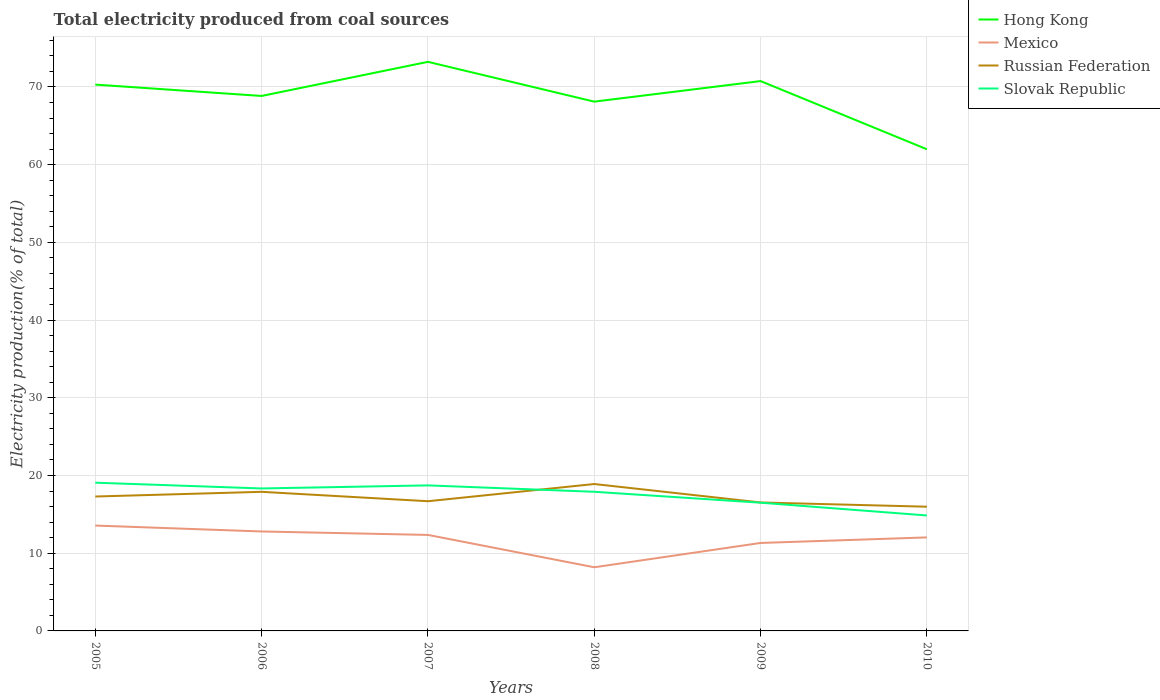Across all years, what is the maximum total electricity produced in Mexico?
Provide a short and direct response. 8.19. What is the total total electricity produced in Mexico in the graph?
Offer a terse response. 0.32. What is the difference between the highest and the second highest total electricity produced in Russian Federation?
Provide a short and direct response. 2.92. What is the difference between the highest and the lowest total electricity produced in Mexico?
Offer a very short reply. 4. How many lines are there?
Your answer should be compact. 4. What is the title of the graph?
Your answer should be very brief. Total electricity produced from coal sources. What is the label or title of the X-axis?
Provide a short and direct response. Years. What is the label or title of the Y-axis?
Your answer should be compact. Electricity production(% of total). What is the Electricity production(% of total) of Hong Kong in 2005?
Offer a terse response. 70.3. What is the Electricity production(% of total) in Mexico in 2005?
Give a very brief answer. 13.56. What is the Electricity production(% of total) of Russian Federation in 2005?
Make the answer very short. 17.3. What is the Electricity production(% of total) of Slovak Republic in 2005?
Keep it short and to the point. 19.07. What is the Electricity production(% of total) of Hong Kong in 2006?
Make the answer very short. 68.84. What is the Electricity production(% of total) of Mexico in 2006?
Give a very brief answer. 12.8. What is the Electricity production(% of total) of Russian Federation in 2006?
Keep it short and to the point. 17.9. What is the Electricity production(% of total) of Slovak Republic in 2006?
Provide a short and direct response. 18.33. What is the Electricity production(% of total) in Hong Kong in 2007?
Your answer should be compact. 73.23. What is the Electricity production(% of total) in Mexico in 2007?
Provide a short and direct response. 12.35. What is the Electricity production(% of total) of Russian Federation in 2007?
Ensure brevity in your answer.  16.69. What is the Electricity production(% of total) in Slovak Republic in 2007?
Make the answer very short. 18.73. What is the Electricity production(% of total) of Hong Kong in 2008?
Keep it short and to the point. 68.11. What is the Electricity production(% of total) of Mexico in 2008?
Ensure brevity in your answer.  8.19. What is the Electricity production(% of total) in Russian Federation in 2008?
Provide a short and direct response. 18.9. What is the Electricity production(% of total) in Slovak Republic in 2008?
Provide a short and direct response. 17.9. What is the Electricity production(% of total) in Hong Kong in 2009?
Your answer should be compact. 70.75. What is the Electricity production(% of total) of Mexico in 2009?
Provide a short and direct response. 11.32. What is the Electricity production(% of total) of Russian Federation in 2009?
Your answer should be compact. 16.53. What is the Electricity production(% of total) of Slovak Republic in 2009?
Make the answer very short. 16.5. What is the Electricity production(% of total) in Hong Kong in 2010?
Your answer should be compact. 61.98. What is the Electricity production(% of total) of Mexico in 2010?
Offer a terse response. 12.03. What is the Electricity production(% of total) of Russian Federation in 2010?
Provide a short and direct response. 15.98. What is the Electricity production(% of total) of Slovak Republic in 2010?
Keep it short and to the point. 14.86. Across all years, what is the maximum Electricity production(% of total) of Hong Kong?
Offer a terse response. 73.23. Across all years, what is the maximum Electricity production(% of total) of Mexico?
Make the answer very short. 13.56. Across all years, what is the maximum Electricity production(% of total) of Russian Federation?
Offer a terse response. 18.9. Across all years, what is the maximum Electricity production(% of total) in Slovak Republic?
Your answer should be compact. 19.07. Across all years, what is the minimum Electricity production(% of total) of Hong Kong?
Give a very brief answer. 61.98. Across all years, what is the minimum Electricity production(% of total) of Mexico?
Your answer should be very brief. 8.19. Across all years, what is the minimum Electricity production(% of total) in Russian Federation?
Your response must be concise. 15.98. Across all years, what is the minimum Electricity production(% of total) in Slovak Republic?
Provide a succinct answer. 14.86. What is the total Electricity production(% of total) of Hong Kong in the graph?
Keep it short and to the point. 413.19. What is the total Electricity production(% of total) of Mexico in the graph?
Ensure brevity in your answer.  70.25. What is the total Electricity production(% of total) in Russian Federation in the graph?
Provide a succinct answer. 103.3. What is the total Electricity production(% of total) of Slovak Republic in the graph?
Offer a very short reply. 105.39. What is the difference between the Electricity production(% of total) in Hong Kong in 2005 and that in 2006?
Make the answer very short. 1.46. What is the difference between the Electricity production(% of total) in Mexico in 2005 and that in 2006?
Ensure brevity in your answer.  0.76. What is the difference between the Electricity production(% of total) in Russian Federation in 2005 and that in 2006?
Provide a succinct answer. -0.6. What is the difference between the Electricity production(% of total) in Slovak Republic in 2005 and that in 2006?
Keep it short and to the point. 0.74. What is the difference between the Electricity production(% of total) in Hong Kong in 2005 and that in 2007?
Offer a very short reply. -2.93. What is the difference between the Electricity production(% of total) in Mexico in 2005 and that in 2007?
Ensure brevity in your answer.  1.2. What is the difference between the Electricity production(% of total) of Russian Federation in 2005 and that in 2007?
Make the answer very short. 0.61. What is the difference between the Electricity production(% of total) in Slovak Republic in 2005 and that in 2007?
Make the answer very short. 0.35. What is the difference between the Electricity production(% of total) in Hong Kong in 2005 and that in 2008?
Make the answer very short. 2.19. What is the difference between the Electricity production(% of total) in Mexico in 2005 and that in 2008?
Give a very brief answer. 5.37. What is the difference between the Electricity production(% of total) of Russian Federation in 2005 and that in 2008?
Provide a short and direct response. -1.61. What is the difference between the Electricity production(% of total) of Slovak Republic in 2005 and that in 2008?
Your response must be concise. 1.17. What is the difference between the Electricity production(% of total) in Hong Kong in 2005 and that in 2009?
Provide a short and direct response. -0.45. What is the difference between the Electricity production(% of total) in Mexico in 2005 and that in 2009?
Keep it short and to the point. 2.24. What is the difference between the Electricity production(% of total) of Russian Federation in 2005 and that in 2009?
Your answer should be very brief. 0.77. What is the difference between the Electricity production(% of total) in Slovak Republic in 2005 and that in 2009?
Your answer should be very brief. 2.58. What is the difference between the Electricity production(% of total) in Hong Kong in 2005 and that in 2010?
Keep it short and to the point. 8.32. What is the difference between the Electricity production(% of total) of Mexico in 2005 and that in 2010?
Offer a terse response. 1.52. What is the difference between the Electricity production(% of total) of Russian Federation in 2005 and that in 2010?
Offer a terse response. 1.31. What is the difference between the Electricity production(% of total) of Slovak Republic in 2005 and that in 2010?
Offer a terse response. 4.22. What is the difference between the Electricity production(% of total) in Hong Kong in 2006 and that in 2007?
Give a very brief answer. -4.39. What is the difference between the Electricity production(% of total) of Mexico in 2006 and that in 2007?
Offer a very short reply. 0.44. What is the difference between the Electricity production(% of total) of Russian Federation in 2006 and that in 2007?
Provide a succinct answer. 1.21. What is the difference between the Electricity production(% of total) of Slovak Republic in 2006 and that in 2007?
Your response must be concise. -0.39. What is the difference between the Electricity production(% of total) of Hong Kong in 2006 and that in 2008?
Your answer should be compact. 0.73. What is the difference between the Electricity production(% of total) of Mexico in 2006 and that in 2008?
Your response must be concise. 4.61. What is the difference between the Electricity production(% of total) in Russian Federation in 2006 and that in 2008?
Offer a terse response. -1. What is the difference between the Electricity production(% of total) of Slovak Republic in 2006 and that in 2008?
Provide a short and direct response. 0.43. What is the difference between the Electricity production(% of total) in Hong Kong in 2006 and that in 2009?
Your response must be concise. -1.91. What is the difference between the Electricity production(% of total) in Mexico in 2006 and that in 2009?
Offer a terse response. 1.48. What is the difference between the Electricity production(% of total) of Russian Federation in 2006 and that in 2009?
Your response must be concise. 1.37. What is the difference between the Electricity production(% of total) of Slovak Republic in 2006 and that in 2009?
Keep it short and to the point. 1.83. What is the difference between the Electricity production(% of total) in Hong Kong in 2006 and that in 2010?
Make the answer very short. 6.86. What is the difference between the Electricity production(% of total) in Mexico in 2006 and that in 2010?
Provide a succinct answer. 0.76. What is the difference between the Electricity production(% of total) in Russian Federation in 2006 and that in 2010?
Give a very brief answer. 1.91. What is the difference between the Electricity production(% of total) of Slovak Republic in 2006 and that in 2010?
Offer a very short reply. 3.48. What is the difference between the Electricity production(% of total) in Hong Kong in 2007 and that in 2008?
Your response must be concise. 5.12. What is the difference between the Electricity production(% of total) in Mexico in 2007 and that in 2008?
Offer a terse response. 4.16. What is the difference between the Electricity production(% of total) of Russian Federation in 2007 and that in 2008?
Your answer should be very brief. -2.21. What is the difference between the Electricity production(% of total) in Slovak Republic in 2007 and that in 2008?
Provide a short and direct response. 0.82. What is the difference between the Electricity production(% of total) in Hong Kong in 2007 and that in 2009?
Provide a short and direct response. 2.48. What is the difference between the Electricity production(% of total) in Mexico in 2007 and that in 2009?
Your answer should be very brief. 1.03. What is the difference between the Electricity production(% of total) of Russian Federation in 2007 and that in 2009?
Your response must be concise. 0.16. What is the difference between the Electricity production(% of total) of Slovak Republic in 2007 and that in 2009?
Offer a terse response. 2.23. What is the difference between the Electricity production(% of total) in Hong Kong in 2007 and that in 2010?
Ensure brevity in your answer.  11.25. What is the difference between the Electricity production(% of total) of Mexico in 2007 and that in 2010?
Keep it short and to the point. 0.32. What is the difference between the Electricity production(% of total) in Russian Federation in 2007 and that in 2010?
Give a very brief answer. 0.71. What is the difference between the Electricity production(% of total) in Slovak Republic in 2007 and that in 2010?
Offer a terse response. 3.87. What is the difference between the Electricity production(% of total) in Hong Kong in 2008 and that in 2009?
Give a very brief answer. -2.64. What is the difference between the Electricity production(% of total) of Mexico in 2008 and that in 2009?
Give a very brief answer. -3.13. What is the difference between the Electricity production(% of total) of Russian Federation in 2008 and that in 2009?
Make the answer very short. 2.37. What is the difference between the Electricity production(% of total) in Slovak Republic in 2008 and that in 2009?
Ensure brevity in your answer.  1.41. What is the difference between the Electricity production(% of total) in Hong Kong in 2008 and that in 2010?
Your response must be concise. 6.13. What is the difference between the Electricity production(% of total) in Mexico in 2008 and that in 2010?
Your answer should be compact. -3.84. What is the difference between the Electricity production(% of total) in Russian Federation in 2008 and that in 2010?
Make the answer very short. 2.92. What is the difference between the Electricity production(% of total) in Slovak Republic in 2008 and that in 2010?
Offer a terse response. 3.05. What is the difference between the Electricity production(% of total) of Hong Kong in 2009 and that in 2010?
Your answer should be compact. 8.78. What is the difference between the Electricity production(% of total) of Mexico in 2009 and that in 2010?
Offer a very short reply. -0.71. What is the difference between the Electricity production(% of total) of Russian Federation in 2009 and that in 2010?
Keep it short and to the point. 0.55. What is the difference between the Electricity production(% of total) in Slovak Republic in 2009 and that in 2010?
Your answer should be compact. 1.64. What is the difference between the Electricity production(% of total) of Hong Kong in 2005 and the Electricity production(% of total) of Mexico in 2006?
Provide a succinct answer. 57.5. What is the difference between the Electricity production(% of total) of Hong Kong in 2005 and the Electricity production(% of total) of Russian Federation in 2006?
Provide a short and direct response. 52.4. What is the difference between the Electricity production(% of total) in Hong Kong in 2005 and the Electricity production(% of total) in Slovak Republic in 2006?
Your response must be concise. 51.97. What is the difference between the Electricity production(% of total) of Mexico in 2005 and the Electricity production(% of total) of Russian Federation in 2006?
Your response must be concise. -4.34. What is the difference between the Electricity production(% of total) of Mexico in 2005 and the Electricity production(% of total) of Slovak Republic in 2006?
Make the answer very short. -4.78. What is the difference between the Electricity production(% of total) of Russian Federation in 2005 and the Electricity production(% of total) of Slovak Republic in 2006?
Offer a terse response. -1.04. What is the difference between the Electricity production(% of total) of Hong Kong in 2005 and the Electricity production(% of total) of Mexico in 2007?
Provide a short and direct response. 57.94. What is the difference between the Electricity production(% of total) of Hong Kong in 2005 and the Electricity production(% of total) of Russian Federation in 2007?
Your response must be concise. 53.61. What is the difference between the Electricity production(% of total) of Hong Kong in 2005 and the Electricity production(% of total) of Slovak Republic in 2007?
Your response must be concise. 51.57. What is the difference between the Electricity production(% of total) in Mexico in 2005 and the Electricity production(% of total) in Russian Federation in 2007?
Give a very brief answer. -3.13. What is the difference between the Electricity production(% of total) of Mexico in 2005 and the Electricity production(% of total) of Slovak Republic in 2007?
Provide a succinct answer. -5.17. What is the difference between the Electricity production(% of total) in Russian Federation in 2005 and the Electricity production(% of total) in Slovak Republic in 2007?
Give a very brief answer. -1.43. What is the difference between the Electricity production(% of total) of Hong Kong in 2005 and the Electricity production(% of total) of Mexico in 2008?
Offer a very short reply. 62.11. What is the difference between the Electricity production(% of total) in Hong Kong in 2005 and the Electricity production(% of total) in Russian Federation in 2008?
Keep it short and to the point. 51.4. What is the difference between the Electricity production(% of total) in Hong Kong in 2005 and the Electricity production(% of total) in Slovak Republic in 2008?
Provide a short and direct response. 52.39. What is the difference between the Electricity production(% of total) of Mexico in 2005 and the Electricity production(% of total) of Russian Federation in 2008?
Give a very brief answer. -5.35. What is the difference between the Electricity production(% of total) of Mexico in 2005 and the Electricity production(% of total) of Slovak Republic in 2008?
Provide a succinct answer. -4.35. What is the difference between the Electricity production(% of total) in Russian Federation in 2005 and the Electricity production(% of total) in Slovak Republic in 2008?
Offer a terse response. -0.61. What is the difference between the Electricity production(% of total) of Hong Kong in 2005 and the Electricity production(% of total) of Mexico in 2009?
Your answer should be very brief. 58.98. What is the difference between the Electricity production(% of total) in Hong Kong in 2005 and the Electricity production(% of total) in Russian Federation in 2009?
Your response must be concise. 53.77. What is the difference between the Electricity production(% of total) in Hong Kong in 2005 and the Electricity production(% of total) in Slovak Republic in 2009?
Offer a very short reply. 53.8. What is the difference between the Electricity production(% of total) of Mexico in 2005 and the Electricity production(% of total) of Russian Federation in 2009?
Provide a short and direct response. -2.97. What is the difference between the Electricity production(% of total) in Mexico in 2005 and the Electricity production(% of total) in Slovak Republic in 2009?
Your response must be concise. -2.94. What is the difference between the Electricity production(% of total) in Russian Federation in 2005 and the Electricity production(% of total) in Slovak Republic in 2009?
Provide a short and direct response. 0.8. What is the difference between the Electricity production(% of total) of Hong Kong in 2005 and the Electricity production(% of total) of Mexico in 2010?
Make the answer very short. 58.26. What is the difference between the Electricity production(% of total) of Hong Kong in 2005 and the Electricity production(% of total) of Russian Federation in 2010?
Make the answer very short. 54.31. What is the difference between the Electricity production(% of total) of Hong Kong in 2005 and the Electricity production(% of total) of Slovak Republic in 2010?
Your answer should be compact. 55.44. What is the difference between the Electricity production(% of total) in Mexico in 2005 and the Electricity production(% of total) in Russian Federation in 2010?
Keep it short and to the point. -2.43. What is the difference between the Electricity production(% of total) in Mexico in 2005 and the Electricity production(% of total) in Slovak Republic in 2010?
Provide a succinct answer. -1.3. What is the difference between the Electricity production(% of total) in Russian Federation in 2005 and the Electricity production(% of total) in Slovak Republic in 2010?
Your response must be concise. 2.44. What is the difference between the Electricity production(% of total) in Hong Kong in 2006 and the Electricity production(% of total) in Mexico in 2007?
Keep it short and to the point. 56.48. What is the difference between the Electricity production(% of total) in Hong Kong in 2006 and the Electricity production(% of total) in Russian Federation in 2007?
Your response must be concise. 52.15. What is the difference between the Electricity production(% of total) in Hong Kong in 2006 and the Electricity production(% of total) in Slovak Republic in 2007?
Your response must be concise. 50.11. What is the difference between the Electricity production(% of total) in Mexico in 2006 and the Electricity production(% of total) in Russian Federation in 2007?
Ensure brevity in your answer.  -3.89. What is the difference between the Electricity production(% of total) of Mexico in 2006 and the Electricity production(% of total) of Slovak Republic in 2007?
Give a very brief answer. -5.93. What is the difference between the Electricity production(% of total) in Russian Federation in 2006 and the Electricity production(% of total) in Slovak Republic in 2007?
Offer a very short reply. -0.83. What is the difference between the Electricity production(% of total) of Hong Kong in 2006 and the Electricity production(% of total) of Mexico in 2008?
Your response must be concise. 60.65. What is the difference between the Electricity production(% of total) of Hong Kong in 2006 and the Electricity production(% of total) of Russian Federation in 2008?
Provide a succinct answer. 49.94. What is the difference between the Electricity production(% of total) of Hong Kong in 2006 and the Electricity production(% of total) of Slovak Republic in 2008?
Provide a short and direct response. 50.93. What is the difference between the Electricity production(% of total) of Mexico in 2006 and the Electricity production(% of total) of Russian Federation in 2008?
Keep it short and to the point. -6.1. What is the difference between the Electricity production(% of total) in Mexico in 2006 and the Electricity production(% of total) in Slovak Republic in 2008?
Your answer should be compact. -5.11. What is the difference between the Electricity production(% of total) in Russian Federation in 2006 and the Electricity production(% of total) in Slovak Republic in 2008?
Offer a very short reply. -0.01. What is the difference between the Electricity production(% of total) in Hong Kong in 2006 and the Electricity production(% of total) in Mexico in 2009?
Give a very brief answer. 57.52. What is the difference between the Electricity production(% of total) of Hong Kong in 2006 and the Electricity production(% of total) of Russian Federation in 2009?
Provide a succinct answer. 52.31. What is the difference between the Electricity production(% of total) of Hong Kong in 2006 and the Electricity production(% of total) of Slovak Republic in 2009?
Your answer should be compact. 52.34. What is the difference between the Electricity production(% of total) of Mexico in 2006 and the Electricity production(% of total) of Russian Federation in 2009?
Give a very brief answer. -3.73. What is the difference between the Electricity production(% of total) of Mexico in 2006 and the Electricity production(% of total) of Slovak Republic in 2009?
Offer a very short reply. -3.7. What is the difference between the Electricity production(% of total) of Russian Federation in 2006 and the Electricity production(% of total) of Slovak Republic in 2009?
Give a very brief answer. 1.4. What is the difference between the Electricity production(% of total) of Hong Kong in 2006 and the Electricity production(% of total) of Mexico in 2010?
Offer a very short reply. 56.8. What is the difference between the Electricity production(% of total) of Hong Kong in 2006 and the Electricity production(% of total) of Russian Federation in 2010?
Give a very brief answer. 52.85. What is the difference between the Electricity production(% of total) in Hong Kong in 2006 and the Electricity production(% of total) in Slovak Republic in 2010?
Keep it short and to the point. 53.98. What is the difference between the Electricity production(% of total) of Mexico in 2006 and the Electricity production(% of total) of Russian Federation in 2010?
Offer a very short reply. -3.19. What is the difference between the Electricity production(% of total) in Mexico in 2006 and the Electricity production(% of total) in Slovak Republic in 2010?
Give a very brief answer. -2.06. What is the difference between the Electricity production(% of total) of Russian Federation in 2006 and the Electricity production(% of total) of Slovak Republic in 2010?
Your answer should be compact. 3.04. What is the difference between the Electricity production(% of total) of Hong Kong in 2007 and the Electricity production(% of total) of Mexico in 2008?
Give a very brief answer. 65.04. What is the difference between the Electricity production(% of total) in Hong Kong in 2007 and the Electricity production(% of total) in Russian Federation in 2008?
Ensure brevity in your answer.  54.32. What is the difference between the Electricity production(% of total) of Hong Kong in 2007 and the Electricity production(% of total) of Slovak Republic in 2008?
Your answer should be very brief. 55.32. What is the difference between the Electricity production(% of total) in Mexico in 2007 and the Electricity production(% of total) in Russian Federation in 2008?
Provide a short and direct response. -6.55. What is the difference between the Electricity production(% of total) of Mexico in 2007 and the Electricity production(% of total) of Slovak Republic in 2008?
Offer a terse response. -5.55. What is the difference between the Electricity production(% of total) of Russian Federation in 2007 and the Electricity production(% of total) of Slovak Republic in 2008?
Ensure brevity in your answer.  -1.21. What is the difference between the Electricity production(% of total) of Hong Kong in 2007 and the Electricity production(% of total) of Mexico in 2009?
Provide a short and direct response. 61.91. What is the difference between the Electricity production(% of total) in Hong Kong in 2007 and the Electricity production(% of total) in Russian Federation in 2009?
Offer a very short reply. 56.7. What is the difference between the Electricity production(% of total) of Hong Kong in 2007 and the Electricity production(% of total) of Slovak Republic in 2009?
Provide a short and direct response. 56.73. What is the difference between the Electricity production(% of total) of Mexico in 2007 and the Electricity production(% of total) of Russian Federation in 2009?
Provide a short and direct response. -4.18. What is the difference between the Electricity production(% of total) of Mexico in 2007 and the Electricity production(% of total) of Slovak Republic in 2009?
Provide a short and direct response. -4.14. What is the difference between the Electricity production(% of total) in Russian Federation in 2007 and the Electricity production(% of total) in Slovak Republic in 2009?
Your answer should be compact. 0.19. What is the difference between the Electricity production(% of total) in Hong Kong in 2007 and the Electricity production(% of total) in Mexico in 2010?
Your answer should be very brief. 61.19. What is the difference between the Electricity production(% of total) of Hong Kong in 2007 and the Electricity production(% of total) of Russian Federation in 2010?
Provide a succinct answer. 57.24. What is the difference between the Electricity production(% of total) in Hong Kong in 2007 and the Electricity production(% of total) in Slovak Republic in 2010?
Ensure brevity in your answer.  58.37. What is the difference between the Electricity production(% of total) of Mexico in 2007 and the Electricity production(% of total) of Russian Federation in 2010?
Keep it short and to the point. -3.63. What is the difference between the Electricity production(% of total) in Mexico in 2007 and the Electricity production(% of total) in Slovak Republic in 2010?
Your response must be concise. -2.5. What is the difference between the Electricity production(% of total) of Russian Federation in 2007 and the Electricity production(% of total) of Slovak Republic in 2010?
Provide a short and direct response. 1.83. What is the difference between the Electricity production(% of total) in Hong Kong in 2008 and the Electricity production(% of total) in Mexico in 2009?
Offer a terse response. 56.79. What is the difference between the Electricity production(% of total) of Hong Kong in 2008 and the Electricity production(% of total) of Russian Federation in 2009?
Provide a succinct answer. 51.58. What is the difference between the Electricity production(% of total) of Hong Kong in 2008 and the Electricity production(% of total) of Slovak Republic in 2009?
Your response must be concise. 51.61. What is the difference between the Electricity production(% of total) in Mexico in 2008 and the Electricity production(% of total) in Russian Federation in 2009?
Offer a very short reply. -8.34. What is the difference between the Electricity production(% of total) in Mexico in 2008 and the Electricity production(% of total) in Slovak Republic in 2009?
Make the answer very short. -8.31. What is the difference between the Electricity production(% of total) in Russian Federation in 2008 and the Electricity production(% of total) in Slovak Republic in 2009?
Offer a very short reply. 2.4. What is the difference between the Electricity production(% of total) of Hong Kong in 2008 and the Electricity production(% of total) of Mexico in 2010?
Your answer should be compact. 56.07. What is the difference between the Electricity production(% of total) of Hong Kong in 2008 and the Electricity production(% of total) of Russian Federation in 2010?
Your response must be concise. 52.12. What is the difference between the Electricity production(% of total) in Hong Kong in 2008 and the Electricity production(% of total) in Slovak Republic in 2010?
Keep it short and to the point. 53.25. What is the difference between the Electricity production(% of total) in Mexico in 2008 and the Electricity production(% of total) in Russian Federation in 2010?
Offer a terse response. -7.79. What is the difference between the Electricity production(% of total) of Mexico in 2008 and the Electricity production(% of total) of Slovak Republic in 2010?
Make the answer very short. -6.67. What is the difference between the Electricity production(% of total) in Russian Federation in 2008 and the Electricity production(% of total) in Slovak Republic in 2010?
Your answer should be compact. 4.05. What is the difference between the Electricity production(% of total) in Hong Kong in 2009 and the Electricity production(% of total) in Mexico in 2010?
Offer a very short reply. 58.72. What is the difference between the Electricity production(% of total) of Hong Kong in 2009 and the Electricity production(% of total) of Russian Federation in 2010?
Your answer should be compact. 54.77. What is the difference between the Electricity production(% of total) of Hong Kong in 2009 and the Electricity production(% of total) of Slovak Republic in 2010?
Your answer should be compact. 55.89. What is the difference between the Electricity production(% of total) in Mexico in 2009 and the Electricity production(% of total) in Russian Federation in 2010?
Ensure brevity in your answer.  -4.66. What is the difference between the Electricity production(% of total) in Mexico in 2009 and the Electricity production(% of total) in Slovak Republic in 2010?
Offer a very short reply. -3.54. What is the difference between the Electricity production(% of total) in Russian Federation in 2009 and the Electricity production(% of total) in Slovak Republic in 2010?
Offer a terse response. 1.67. What is the average Electricity production(% of total) of Hong Kong per year?
Provide a succinct answer. 68.87. What is the average Electricity production(% of total) in Mexico per year?
Your response must be concise. 11.71. What is the average Electricity production(% of total) in Russian Federation per year?
Make the answer very short. 17.22. What is the average Electricity production(% of total) in Slovak Republic per year?
Your answer should be compact. 17.56. In the year 2005, what is the difference between the Electricity production(% of total) of Hong Kong and Electricity production(% of total) of Mexico?
Your answer should be very brief. 56.74. In the year 2005, what is the difference between the Electricity production(% of total) of Hong Kong and Electricity production(% of total) of Russian Federation?
Give a very brief answer. 53. In the year 2005, what is the difference between the Electricity production(% of total) in Hong Kong and Electricity production(% of total) in Slovak Republic?
Make the answer very short. 51.22. In the year 2005, what is the difference between the Electricity production(% of total) in Mexico and Electricity production(% of total) in Russian Federation?
Your answer should be compact. -3.74. In the year 2005, what is the difference between the Electricity production(% of total) of Mexico and Electricity production(% of total) of Slovak Republic?
Ensure brevity in your answer.  -5.52. In the year 2005, what is the difference between the Electricity production(% of total) of Russian Federation and Electricity production(% of total) of Slovak Republic?
Your answer should be compact. -1.78. In the year 2006, what is the difference between the Electricity production(% of total) in Hong Kong and Electricity production(% of total) in Mexico?
Offer a terse response. 56.04. In the year 2006, what is the difference between the Electricity production(% of total) of Hong Kong and Electricity production(% of total) of Russian Federation?
Offer a terse response. 50.94. In the year 2006, what is the difference between the Electricity production(% of total) in Hong Kong and Electricity production(% of total) in Slovak Republic?
Your answer should be very brief. 50.51. In the year 2006, what is the difference between the Electricity production(% of total) of Mexico and Electricity production(% of total) of Russian Federation?
Provide a short and direct response. -5.1. In the year 2006, what is the difference between the Electricity production(% of total) in Mexico and Electricity production(% of total) in Slovak Republic?
Your answer should be compact. -5.53. In the year 2006, what is the difference between the Electricity production(% of total) of Russian Federation and Electricity production(% of total) of Slovak Republic?
Provide a succinct answer. -0.43. In the year 2007, what is the difference between the Electricity production(% of total) of Hong Kong and Electricity production(% of total) of Mexico?
Your answer should be compact. 60.87. In the year 2007, what is the difference between the Electricity production(% of total) in Hong Kong and Electricity production(% of total) in Russian Federation?
Ensure brevity in your answer.  56.54. In the year 2007, what is the difference between the Electricity production(% of total) in Hong Kong and Electricity production(% of total) in Slovak Republic?
Your answer should be very brief. 54.5. In the year 2007, what is the difference between the Electricity production(% of total) in Mexico and Electricity production(% of total) in Russian Federation?
Ensure brevity in your answer.  -4.34. In the year 2007, what is the difference between the Electricity production(% of total) in Mexico and Electricity production(% of total) in Slovak Republic?
Provide a short and direct response. -6.37. In the year 2007, what is the difference between the Electricity production(% of total) of Russian Federation and Electricity production(% of total) of Slovak Republic?
Give a very brief answer. -2.04. In the year 2008, what is the difference between the Electricity production(% of total) of Hong Kong and Electricity production(% of total) of Mexico?
Provide a succinct answer. 59.91. In the year 2008, what is the difference between the Electricity production(% of total) in Hong Kong and Electricity production(% of total) in Russian Federation?
Your answer should be very brief. 49.2. In the year 2008, what is the difference between the Electricity production(% of total) of Hong Kong and Electricity production(% of total) of Slovak Republic?
Your answer should be very brief. 50.2. In the year 2008, what is the difference between the Electricity production(% of total) of Mexico and Electricity production(% of total) of Russian Federation?
Offer a terse response. -10.71. In the year 2008, what is the difference between the Electricity production(% of total) in Mexico and Electricity production(% of total) in Slovak Republic?
Provide a short and direct response. -9.71. In the year 2009, what is the difference between the Electricity production(% of total) of Hong Kong and Electricity production(% of total) of Mexico?
Your response must be concise. 59.43. In the year 2009, what is the difference between the Electricity production(% of total) of Hong Kong and Electricity production(% of total) of Russian Federation?
Give a very brief answer. 54.22. In the year 2009, what is the difference between the Electricity production(% of total) of Hong Kong and Electricity production(% of total) of Slovak Republic?
Give a very brief answer. 54.25. In the year 2009, what is the difference between the Electricity production(% of total) of Mexico and Electricity production(% of total) of Russian Federation?
Make the answer very short. -5.21. In the year 2009, what is the difference between the Electricity production(% of total) of Mexico and Electricity production(% of total) of Slovak Republic?
Ensure brevity in your answer.  -5.18. In the year 2009, what is the difference between the Electricity production(% of total) of Russian Federation and Electricity production(% of total) of Slovak Republic?
Provide a short and direct response. 0.03. In the year 2010, what is the difference between the Electricity production(% of total) in Hong Kong and Electricity production(% of total) in Mexico?
Offer a terse response. 49.94. In the year 2010, what is the difference between the Electricity production(% of total) of Hong Kong and Electricity production(% of total) of Russian Federation?
Your answer should be very brief. 45.99. In the year 2010, what is the difference between the Electricity production(% of total) in Hong Kong and Electricity production(% of total) in Slovak Republic?
Keep it short and to the point. 47.12. In the year 2010, what is the difference between the Electricity production(% of total) of Mexico and Electricity production(% of total) of Russian Federation?
Your response must be concise. -3.95. In the year 2010, what is the difference between the Electricity production(% of total) of Mexico and Electricity production(% of total) of Slovak Republic?
Provide a succinct answer. -2.82. In the year 2010, what is the difference between the Electricity production(% of total) of Russian Federation and Electricity production(% of total) of Slovak Republic?
Provide a succinct answer. 1.13. What is the ratio of the Electricity production(% of total) of Hong Kong in 2005 to that in 2006?
Offer a very short reply. 1.02. What is the ratio of the Electricity production(% of total) of Mexico in 2005 to that in 2006?
Keep it short and to the point. 1.06. What is the ratio of the Electricity production(% of total) of Russian Federation in 2005 to that in 2006?
Keep it short and to the point. 0.97. What is the ratio of the Electricity production(% of total) in Slovak Republic in 2005 to that in 2006?
Your response must be concise. 1.04. What is the ratio of the Electricity production(% of total) of Mexico in 2005 to that in 2007?
Keep it short and to the point. 1.1. What is the ratio of the Electricity production(% of total) in Russian Federation in 2005 to that in 2007?
Provide a succinct answer. 1.04. What is the ratio of the Electricity production(% of total) in Slovak Republic in 2005 to that in 2007?
Provide a short and direct response. 1.02. What is the ratio of the Electricity production(% of total) in Hong Kong in 2005 to that in 2008?
Offer a very short reply. 1.03. What is the ratio of the Electricity production(% of total) in Mexico in 2005 to that in 2008?
Offer a terse response. 1.66. What is the ratio of the Electricity production(% of total) in Russian Federation in 2005 to that in 2008?
Provide a short and direct response. 0.92. What is the ratio of the Electricity production(% of total) of Slovak Republic in 2005 to that in 2008?
Keep it short and to the point. 1.07. What is the ratio of the Electricity production(% of total) in Mexico in 2005 to that in 2009?
Make the answer very short. 1.2. What is the ratio of the Electricity production(% of total) of Russian Federation in 2005 to that in 2009?
Make the answer very short. 1.05. What is the ratio of the Electricity production(% of total) in Slovak Republic in 2005 to that in 2009?
Your answer should be compact. 1.16. What is the ratio of the Electricity production(% of total) in Hong Kong in 2005 to that in 2010?
Keep it short and to the point. 1.13. What is the ratio of the Electricity production(% of total) of Mexico in 2005 to that in 2010?
Your response must be concise. 1.13. What is the ratio of the Electricity production(% of total) in Russian Federation in 2005 to that in 2010?
Your answer should be very brief. 1.08. What is the ratio of the Electricity production(% of total) of Slovak Republic in 2005 to that in 2010?
Your answer should be compact. 1.28. What is the ratio of the Electricity production(% of total) of Hong Kong in 2006 to that in 2007?
Give a very brief answer. 0.94. What is the ratio of the Electricity production(% of total) of Mexico in 2006 to that in 2007?
Make the answer very short. 1.04. What is the ratio of the Electricity production(% of total) in Russian Federation in 2006 to that in 2007?
Give a very brief answer. 1.07. What is the ratio of the Electricity production(% of total) in Slovak Republic in 2006 to that in 2007?
Keep it short and to the point. 0.98. What is the ratio of the Electricity production(% of total) of Hong Kong in 2006 to that in 2008?
Provide a succinct answer. 1.01. What is the ratio of the Electricity production(% of total) of Mexico in 2006 to that in 2008?
Offer a very short reply. 1.56. What is the ratio of the Electricity production(% of total) in Russian Federation in 2006 to that in 2008?
Ensure brevity in your answer.  0.95. What is the ratio of the Electricity production(% of total) of Hong Kong in 2006 to that in 2009?
Provide a short and direct response. 0.97. What is the ratio of the Electricity production(% of total) in Mexico in 2006 to that in 2009?
Offer a very short reply. 1.13. What is the ratio of the Electricity production(% of total) in Russian Federation in 2006 to that in 2009?
Ensure brevity in your answer.  1.08. What is the ratio of the Electricity production(% of total) of Slovak Republic in 2006 to that in 2009?
Make the answer very short. 1.11. What is the ratio of the Electricity production(% of total) in Hong Kong in 2006 to that in 2010?
Make the answer very short. 1.11. What is the ratio of the Electricity production(% of total) of Mexico in 2006 to that in 2010?
Your answer should be very brief. 1.06. What is the ratio of the Electricity production(% of total) of Russian Federation in 2006 to that in 2010?
Offer a terse response. 1.12. What is the ratio of the Electricity production(% of total) in Slovak Republic in 2006 to that in 2010?
Provide a short and direct response. 1.23. What is the ratio of the Electricity production(% of total) in Hong Kong in 2007 to that in 2008?
Make the answer very short. 1.08. What is the ratio of the Electricity production(% of total) of Mexico in 2007 to that in 2008?
Provide a short and direct response. 1.51. What is the ratio of the Electricity production(% of total) in Russian Federation in 2007 to that in 2008?
Your answer should be very brief. 0.88. What is the ratio of the Electricity production(% of total) in Slovak Republic in 2007 to that in 2008?
Make the answer very short. 1.05. What is the ratio of the Electricity production(% of total) in Hong Kong in 2007 to that in 2009?
Provide a succinct answer. 1.03. What is the ratio of the Electricity production(% of total) in Mexico in 2007 to that in 2009?
Keep it short and to the point. 1.09. What is the ratio of the Electricity production(% of total) in Russian Federation in 2007 to that in 2009?
Make the answer very short. 1.01. What is the ratio of the Electricity production(% of total) of Slovak Republic in 2007 to that in 2009?
Provide a short and direct response. 1.14. What is the ratio of the Electricity production(% of total) in Hong Kong in 2007 to that in 2010?
Provide a short and direct response. 1.18. What is the ratio of the Electricity production(% of total) in Mexico in 2007 to that in 2010?
Ensure brevity in your answer.  1.03. What is the ratio of the Electricity production(% of total) of Russian Federation in 2007 to that in 2010?
Your response must be concise. 1.04. What is the ratio of the Electricity production(% of total) of Slovak Republic in 2007 to that in 2010?
Make the answer very short. 1.26. What is the ratio of the Electricity production(% of total) in Hong Kong in 2008 to that in 2009?
Your answer should be compact. 0.96. What is the ratio of the Electricity production(% of total) in Mexico in 2008 to that in 2009?
Keep it short and to the point. 0.72. What is the ratio of the Electricity production(% of total) of Russian Federation in 2008 to that in 2009?
Your answer should be very brief. 1.14. What is the ratio of the Electricity production(% of total) in Slovak Republic in 2008 to that in 2009?
Your answer should be compact. 1.09. What is the ratio of the Electricity production(% of total) of Hong Kong in 2008 to that in 2010?
Ensure brevity in your answer.  1.1. What is the ratio of the Electricity production(% of total) in Mexico in 2008 to that in 2010?
Keep it short and to the point. 0.68. What is the ratio of the Electricity production(% of total) of Russian Federation in 2008 to that in 2010?
Your answer should be compact. 1.18. What is the ratio of the Electricity production(% of total) in Slovak Republic in 2008 to that in 2010?
Ensure brevity in your answer.  1.21. What is the ratio of the Electricity production(% of total) of Hong Kong in 2009 to that in 2010?
Provide a short and direct response. 1.14. What is the ratio of the Electricity production(% of total) of Mexico in 2009 to that in 2010?
Keep it short and to the point. 0.94. What is the ratio of the Electricity production(% of total) in Russian Federation in 2009 to that in 2010?
Give a very brief answer. 1.03. What is the ratio of the Electricity production(% of total) of Slovak Republic in 2009 to that in 2010?
Give a very brief answer. 1.11. What is the difference between the highest and the second highest Electricity production(% of total) in Hong Kong?
Offer a terse response. 2.48. What is the difference between the highest and the second highest Electricity production(% of total) of Mexico?
Provide a short and direct response. 0.76. What is the difference between the highest and the second highest Electricity production(% of total) of Slovak Republic?
Give a very brief answer. 0.35. What is the difference between the highest and the lowest Electricity production(% of total) in Hong Kong?
Provide a short and direct response. 11.25. What is the difference between the highest and the lowest Electricity production(% of total) in Mexico?
Provide a succinct answer. 5.37. What is the difference between the highest and the lowest Electricity production(% of total) of Russian Federation?
Offer a terse response. 2.92. What is the difference between the highest and the lowest Electricity production(% of total) of Slovak Republic?
Keep it short and to the point. 4.22. 